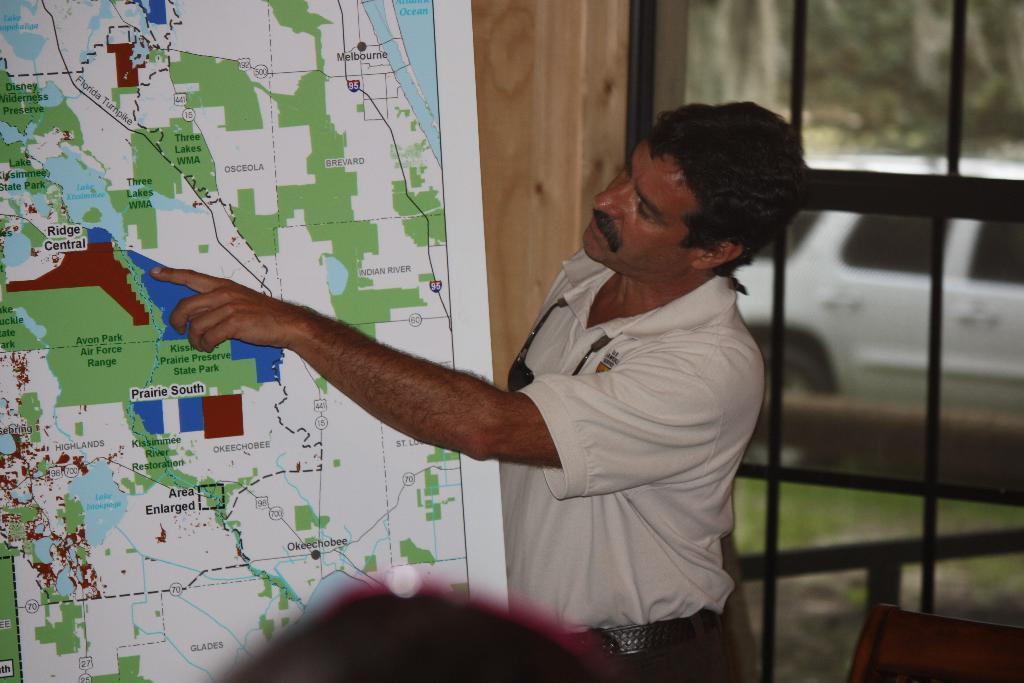Who is present in the image? There is a man in the image. What is the man doing in the image? The man is standing beside a map and explaining something. What can be seen in the background of the image? There is a window in the background of the image. What is visible through the window? There is a vehicle visible through the window. What color is the umbrella that the man is holding in the image? There is no umbrella present in the image; the man is standing beside a map and explaining something. 